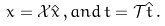<formula> <loc_0><loc_0><loc_500><loc_500>x = { \mathcal { X } } \hat { x } \, , a n d \, t = { \mathcal { T } } \hat { t } \, .</formula> 